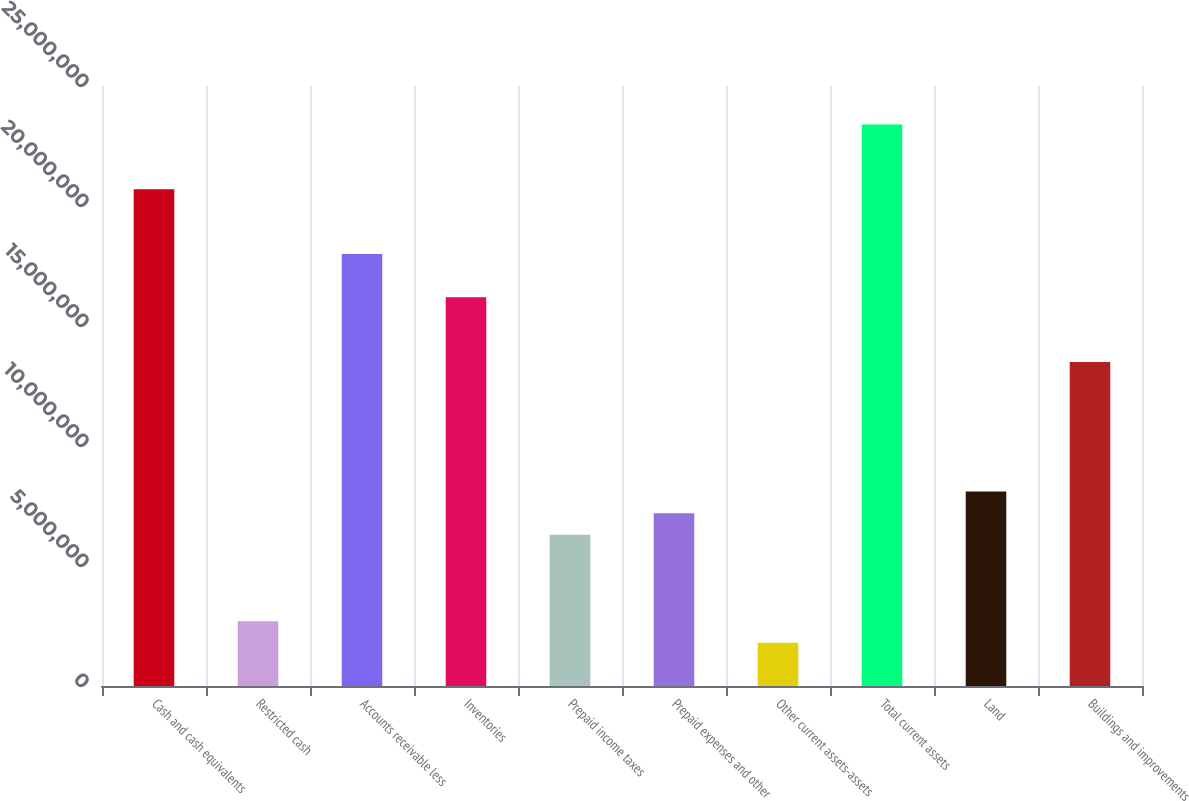<chart> <loc_0><loc_0><loc_500><loc_500><bar_chart><fcel>Cash and cash equivalents<fcel>Restricted cash<fcel>Accounts receivable less<fcel>Inventories<fcel>Prepaid income taxes<fcel>Prepaid expenses and other<fcel>Other current assets-assets<fcel>Total current assets<fcel>Land<fcel>Buildings and improvements<nl><fcel>2.06999e+07<fcel>2.70131e+06<fcel>1.80001e+07<fcel>1.62003e+07<fcel>6.30103e+06<fcel>7.20096e+06<fcel>1.80138e+06<fcel>2.33997e+07<fcel>8.10089e+06<fcel>1.35005e+07<nl></chart> 